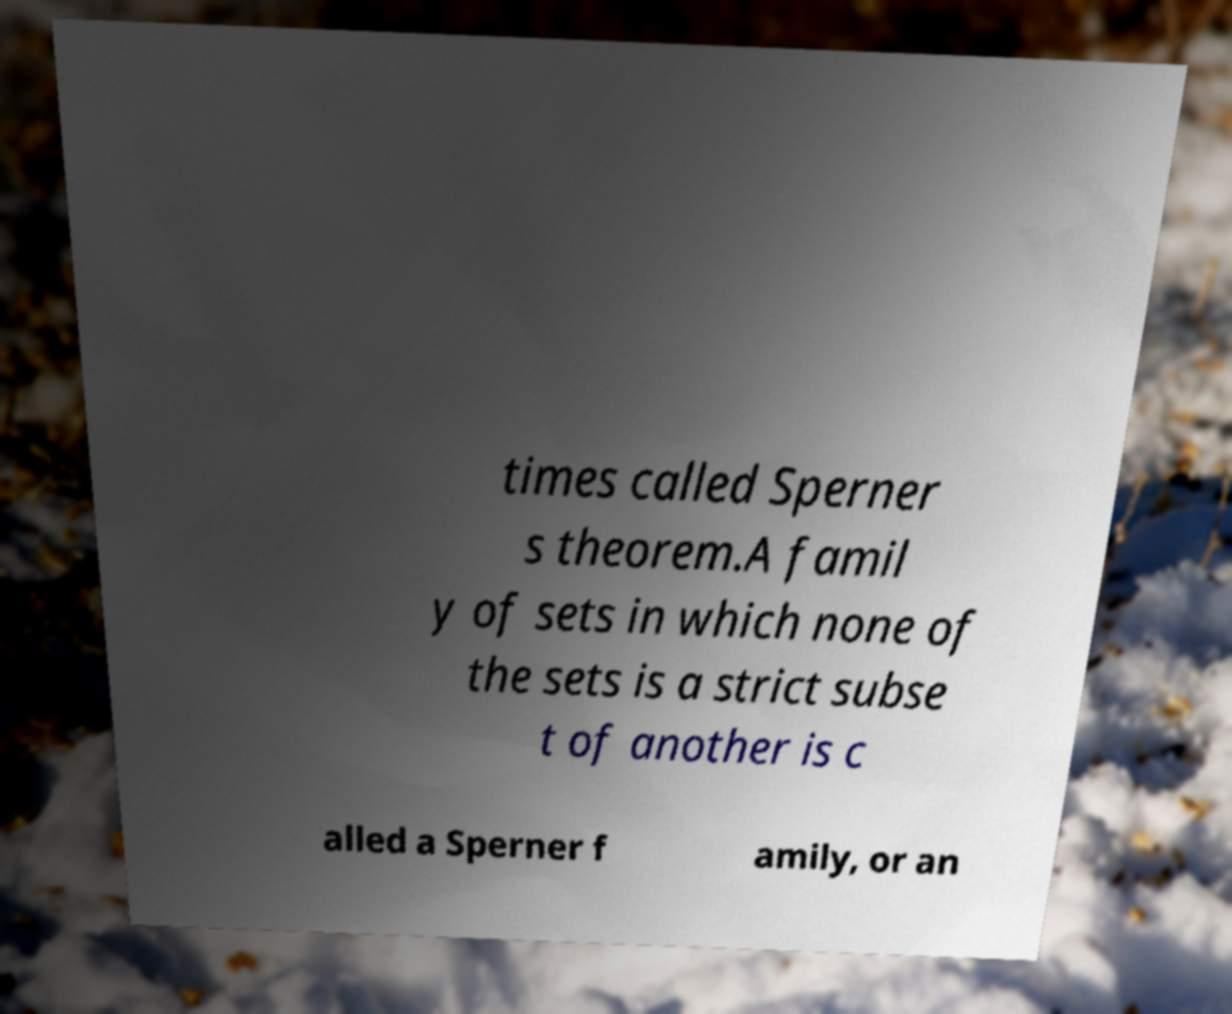Please read and relay the text visible in this image. What does it say? times called Sperner s theorem.A famil y of sets in which none of the sets is a strict subse t of another is c alled a Sperner f amily, or an 